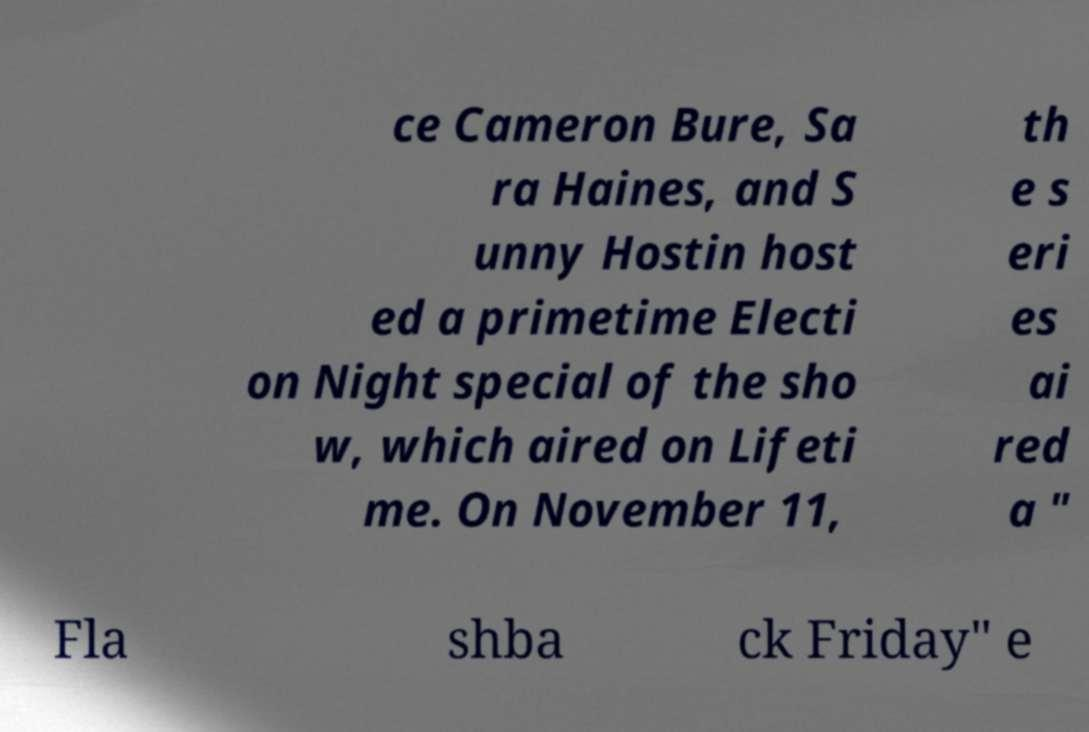For documentation purposes, I need the text within this image transcribed. Could you provide that? ce Cameron Bure, Sa ra Haines, and S unny Hostin host ed a primetime Electi on Night special of the sho w, which aired on Lifeti me. On November 11, th e s eri es ai red a " Fla shba ck Friday" e 